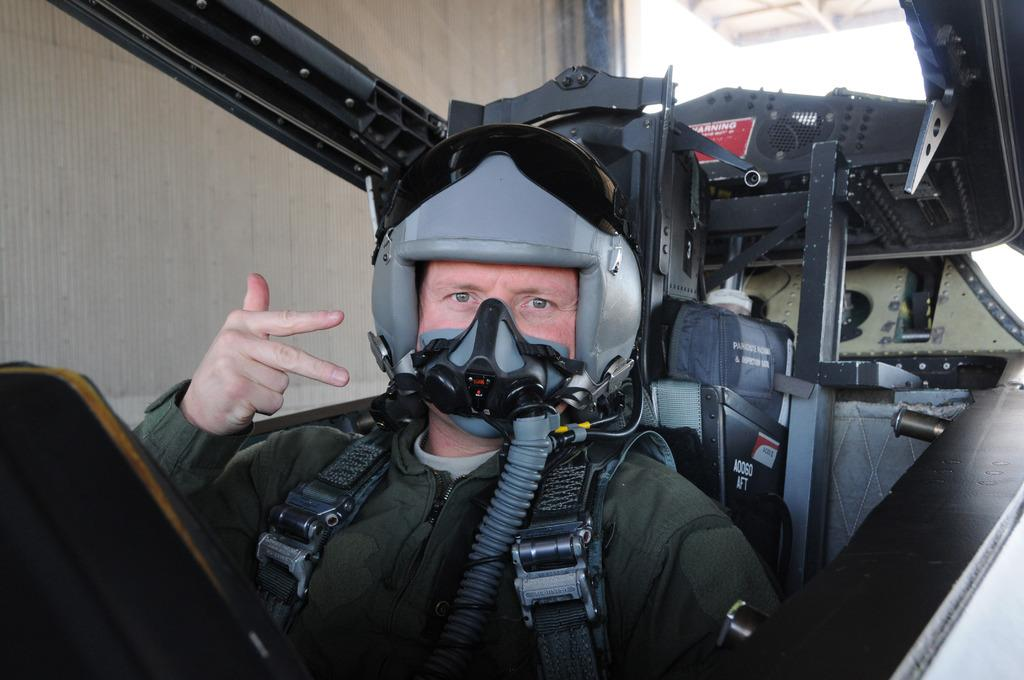What is the person in the image doing? There is a person sitting in the cockpit in the cockpit. What can be seen inside the cockpit? The cockpit has a wall inside it. What type of beef can be seen in the image? There is no beef present in the image; it features a person sitting in a cockpit with a wall inside it. 